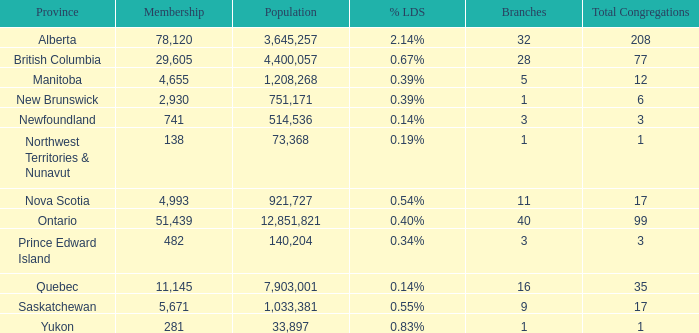What's the fewest number of branches with more than 1 total congregations, a population of 1,033,381, and a membership smaller than 5,671? None. 